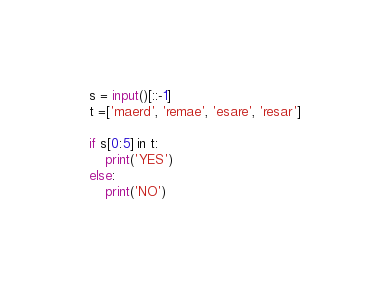<code> <loc_0><loc_0><loc_500><loc_500><_Python_>s = input()[::-1]
t =['maerd', 'remae', 'esare', 'resar']

if s[0:5] in t:
    print('YES')
else:
    print('NO')</code> 